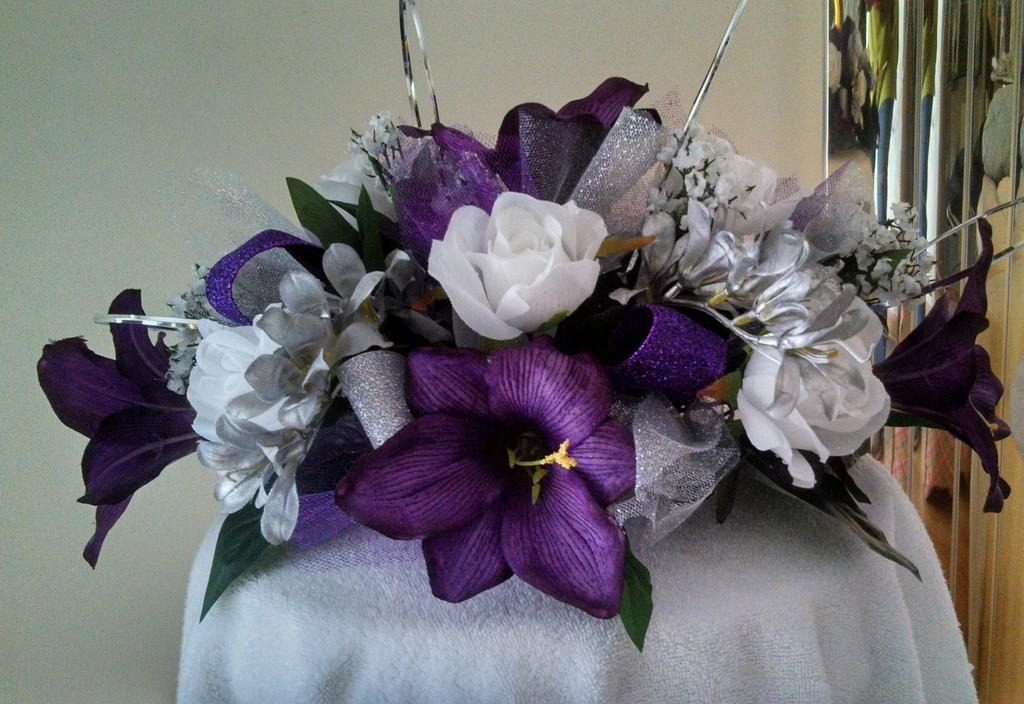What is on the table in the image? There is a bouquet on the table in the image. What can be seen in the background of the image? There is a wall in the background of the image. What is on the right side of the image? There is a curtain on the right side of the image. How many daughters are present in the image? There is no mention of a daughter or any people in the image, so it cannot be determined from the image. 